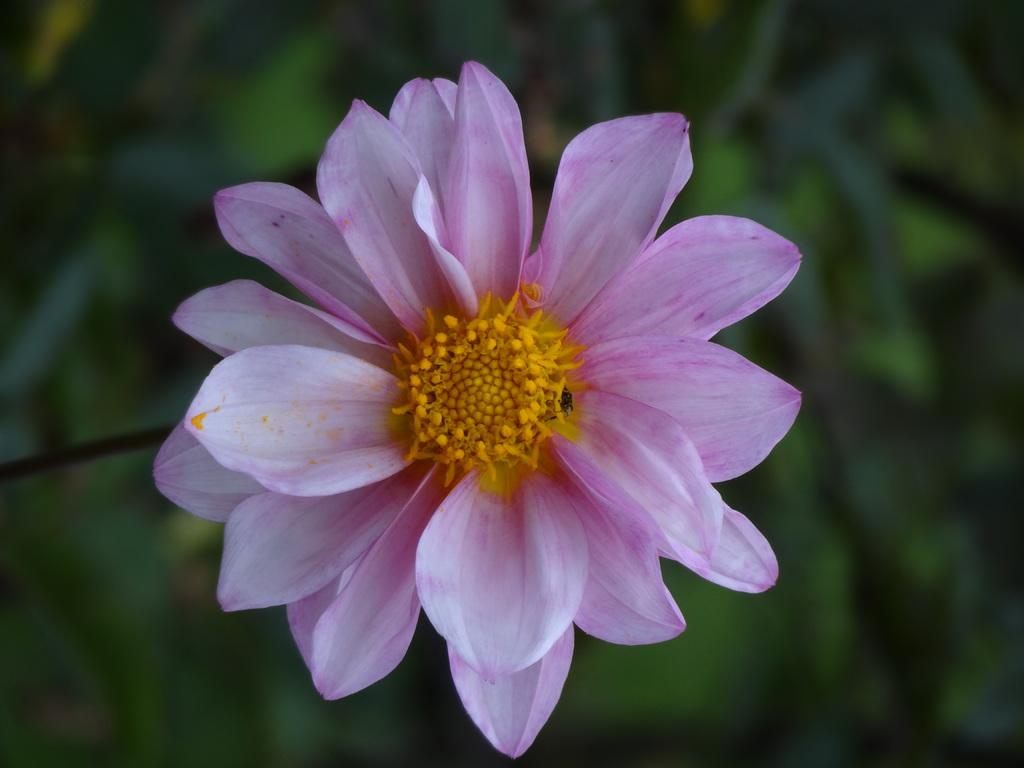What is the main subject of the image? There is a flower in the center of the image. Can you describe the background of the image? The background of the image is blurred. What type of creature can be seen feeding on the flesh in the image? There is no creature or flesh present in the image; it features a flower with a blurred background. 